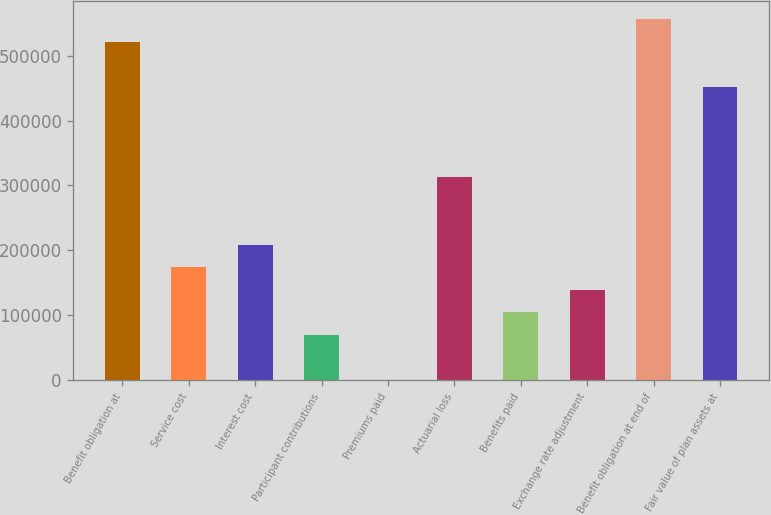Convert chart. <chart><loc_0><loc_0><loc_500><loc_500><bar_chart><fcel>Benefit obligation at<fcel>Service cost<fcel>Interest cost<fcel>Participant contributions<fcel>Premiums paid<fcel>Actuarial loss<fcel>Benefits paid<fcel>Exchange rate adjustment<fcel>Benefit obligation at end of<fcel>Fair value of plan assets at<nl><fcel>521376<fcel>173954<fcel>208697<fcel>69728.2<fcel>244<fcel>312923<fcel>104470<fcel>139212<fcel>556118<fcel>451891<nl></chart> 